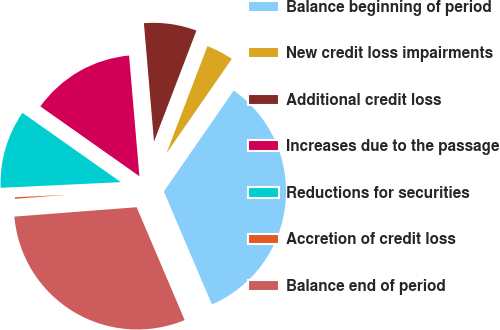Convert chart. <chart><loc_0><loc_0><loc_500><loc_500><pie_chart><fcel>Balance beginning of period<fcel>New credit loss impairments<fcel>Additional credit loss<fcel>Increases due to the passage<fcel>Reductions for securities<fcel>Accretion of credit loss<fcel>Balance end of period<nl><fcel>33.96%<fcel>3.82%<fcel>7.17%<fcel>13.87%<fcel>10.52%<fcel>0.47%<fcel>30.18%<nl></chart> 